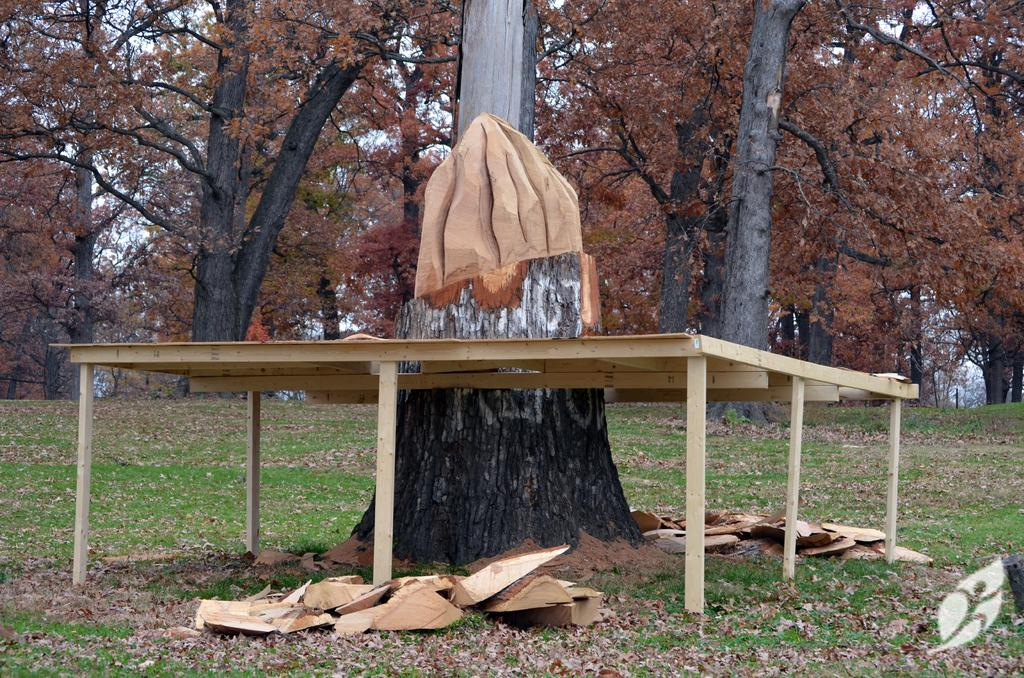What is located in the center of the image? There is a tree and a table in the center of the image. What can be seen in the background of the image? There are trees and the sky visible in the background of the image. What materials are present at the bottom of the image? There is wood and grass at the bottom of the image. How many planes are flying over the tree in the image? There are no planes visible in the image; it only features a tree, a table, trees in the background, the sky, wood, and grass. 